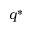<formula> <loc_0><loc_0><loc_500><loc_500>q ^ { * }</formula> 